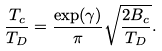Convert formula to latex. <formula><loc_0><loc_0><loc_500><loc_500>\frac { T _ { c } } { T _ { D } } = \frac { \exp ( \gamma ) } { \pi } \sqrt { \frac { 2 B _ { c } } { T _ { D } } } .</formula> 